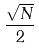Convert formula to latex. <formula><loc_0><loc_0><loc_500><loc_500>\frac { \sqrt { N } } { 2 }</formula> 